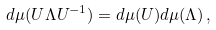Convert formula to latex. <formula><loc_0><loc_0><loc_500><loc_500>d \mu ( U \Lambda U ^ { - 1 } ) = d \mu ( U ) d \mu ( \Lambda ) \, ,</formula> 